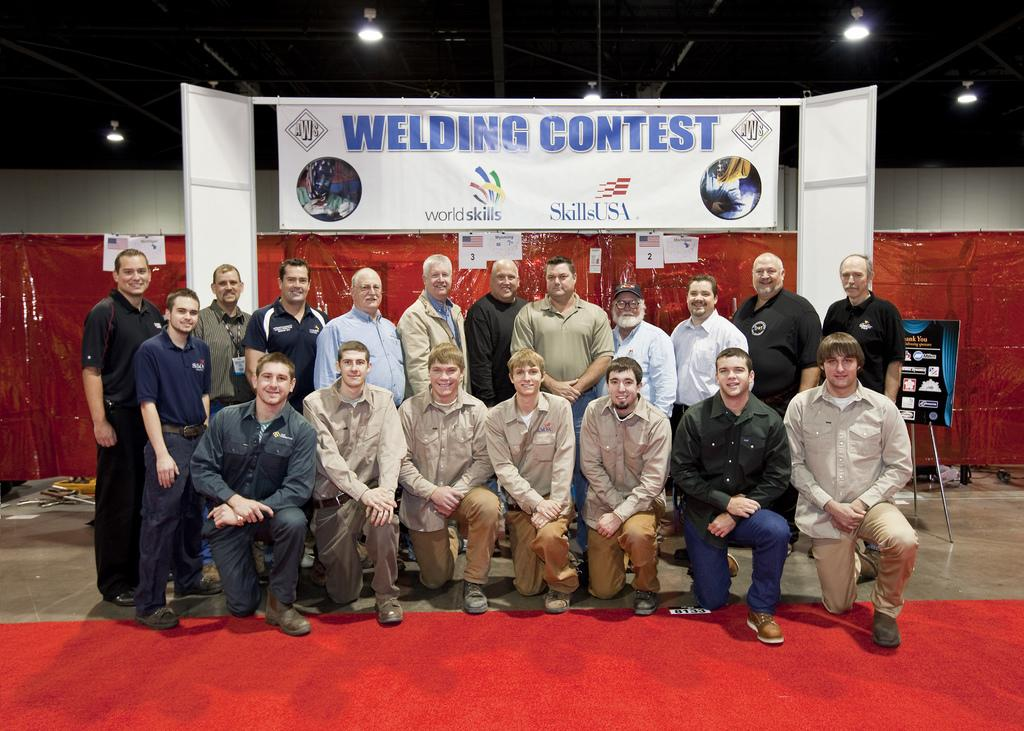What are the people in the image doing? The persons standing on the floor in the image are likely standing or waiting. What can be seen in the background of the image? In the background of the image, there are iron grills, electric lights, advertisement boards, and a carpet. Can you describe the lighting in the image? The presence of electric lights in the background suggests that the image is well-lit. What type of signage is visible in the background of the image? Advertisement boards are visible in the background of the image. Can you see any hens walking around on the carpet in the image? There are no hens present in the image; it features persons standing on the floor and various objects in the background. 